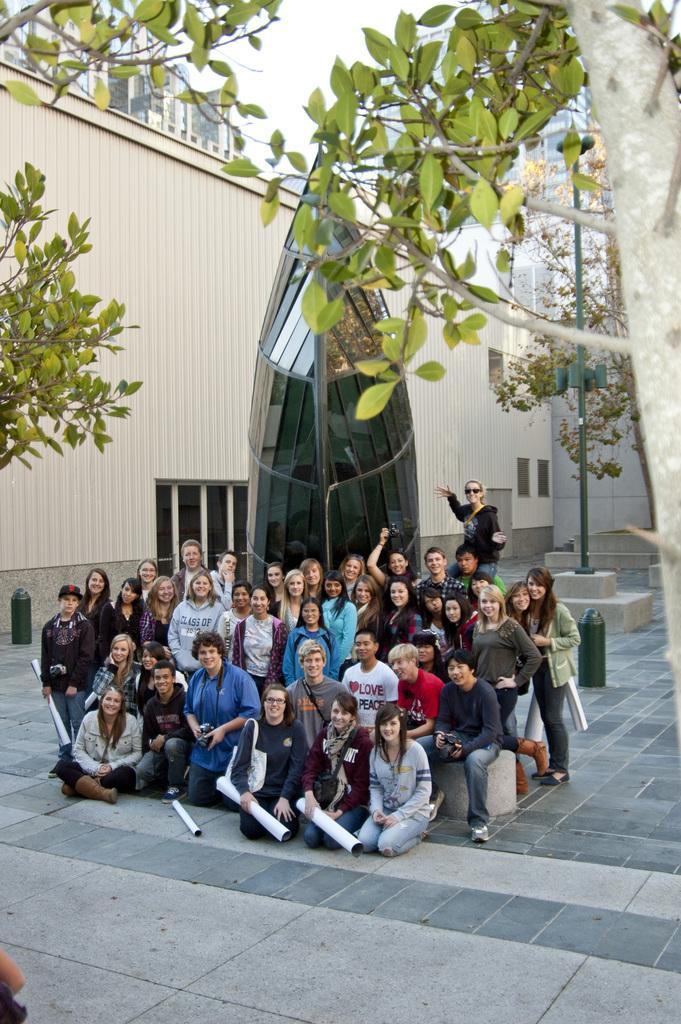In one or two sentences, can you explain what this image depicts? In the center of the image, we can see some people sitting and some are standing and in the background, there are trees, buildings and there is a monument. 